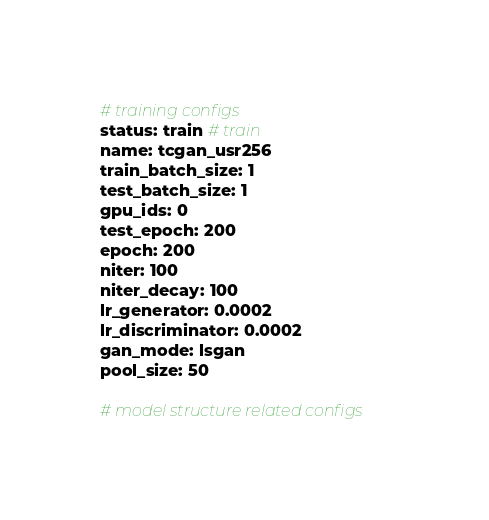Convert code to text. <code><loc_0><loc_0><loc_500><loc_500><_YAML_># training configs
status: train # train
name: tcgan_usr256
train_batch_size: 1
test_batch_size: 1
gpu_ids: 0
test_epoch: 200
epoch: 200
niter: 100
niter_decay: 100
lr_generator: 0.0002
lr_discriminator: 0.0002
gan_mode: lsgan
pool_size: 50

# model structure related configs</code> 